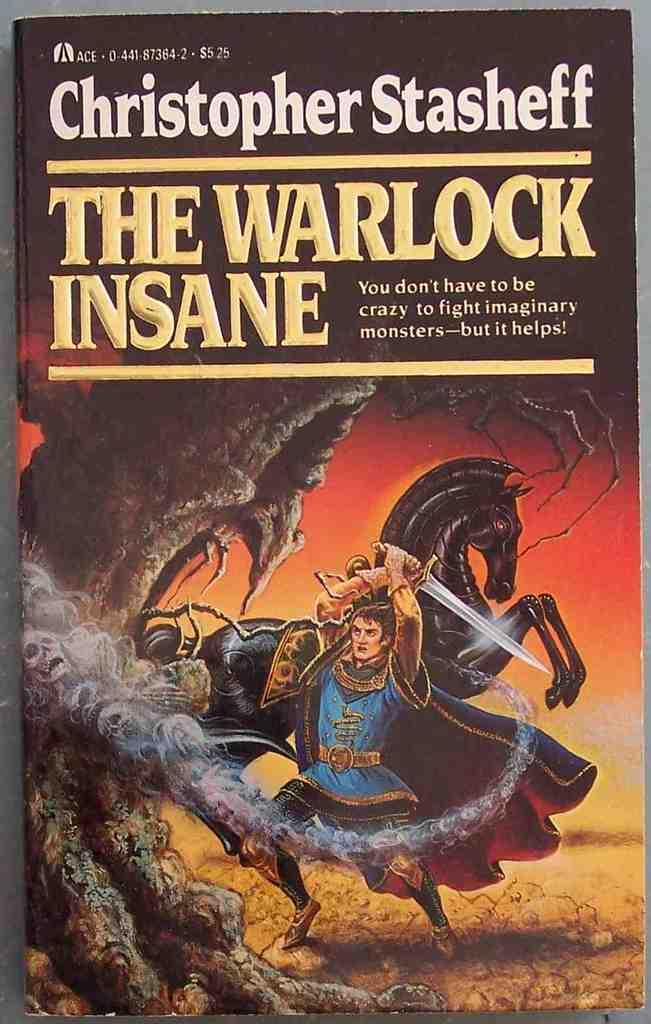Provide a one-sentence caption for the provided image. A man holds a sword on the cover of "The Warlock Insane" book by Christopher Stasheff. 